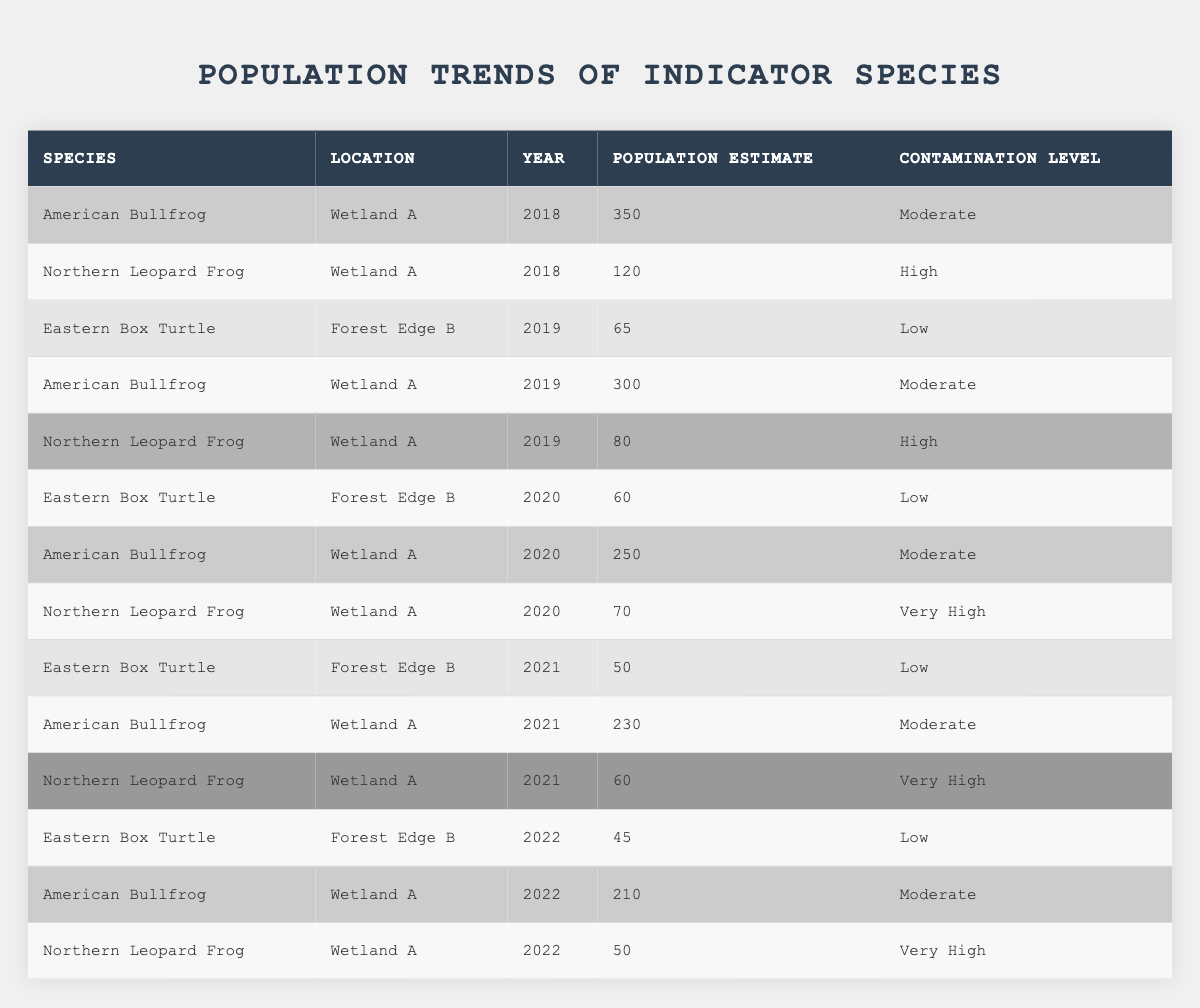What is the population estimate of the American Bullfrog in Wetland A for the year 2020? In the table, we locate the row for the American Bullfrog in Wetland A for the year 2020, which shows a population estimate of 250.
Answer: 250 How many Northern Leopard Frogs were estimated to be in Wetland A in 2019? By checking the table, we find that the population estimate of Northern Leopard Frogs in Wetland A for 2019 is 80.
Answer: 80 What is the contamination level of the Eastern Box Turtle in Forest Edge B for the year 2021? Looking at the table, the Eastern Box Turtle in Forest Edge B for 2021 has a contamination level labeled as Low.
Answer: Low In which year did the population of American Bullfrogs in Wetland A first decline from the previous year's estimate? Observing the table, we see that the population estimate for American Bullfrogs in 2018 is 350, in 2019 it is 300, and in 2020 it declines to 250. Therefore, the first decline occurs from 2018 to 2019.
Answer: 2019 What is the average population estimate for the Northern Leopard Frog from 2018 to 2022? First, we gather the population estimates for Northern Leopard Frogs: 120 (2018), 80 (2019), 70 (2020), 60 (2021), and 50 (2022). We sum these estimates: 120 + 80 + 70 + 60 + 50 = 380, then divide by 5: 380 / 5 = 76.
Answer: 76 Which species had the highest population estimate in 2018, and what was that estimate? Reviewing the table shows that the American Bullfrog had a population estimate of 350 in 2018, which is the highest compared to any other species in the same year.
Answer: American Bullfrog, 350 How did the population estimate of Eastern Box Turtles change from 2019 to 2022? Observing the table, we find the population of Eastern Box Turtles was 65 in 2019, then decreased to 45 in 2022. This indicates a decline of 20 individuals from 2019 to 2022.
Answer: Declined by 20 Was there a year when the Northern Leopard Frog's population estimate was above 100? Checking the table, we find that the highest estimate for Northern Leopard Frogs was 120 in 2018, which is above 100.
Answer: Yes How many indicator species had a population estimate of less than 100 in 2021? From the table, we see that in 2021, the Eastern Box Turtle had a population estimate of 50 and the Northern Leopard Frog had 60, making a total of 2 indicator species with estimates below 100.
Answer: 2 What is the trend for the American Bullfrog's population estimates from 2018 to 2022? Analyzing the table, the estimates for American Bullfrogs show: 350 (2018), 300 (2019), 250 (2020), 230 (2021), and 210 (2022), which demonstrates a consistent decline over the five years.
Answer: Consistent decline 